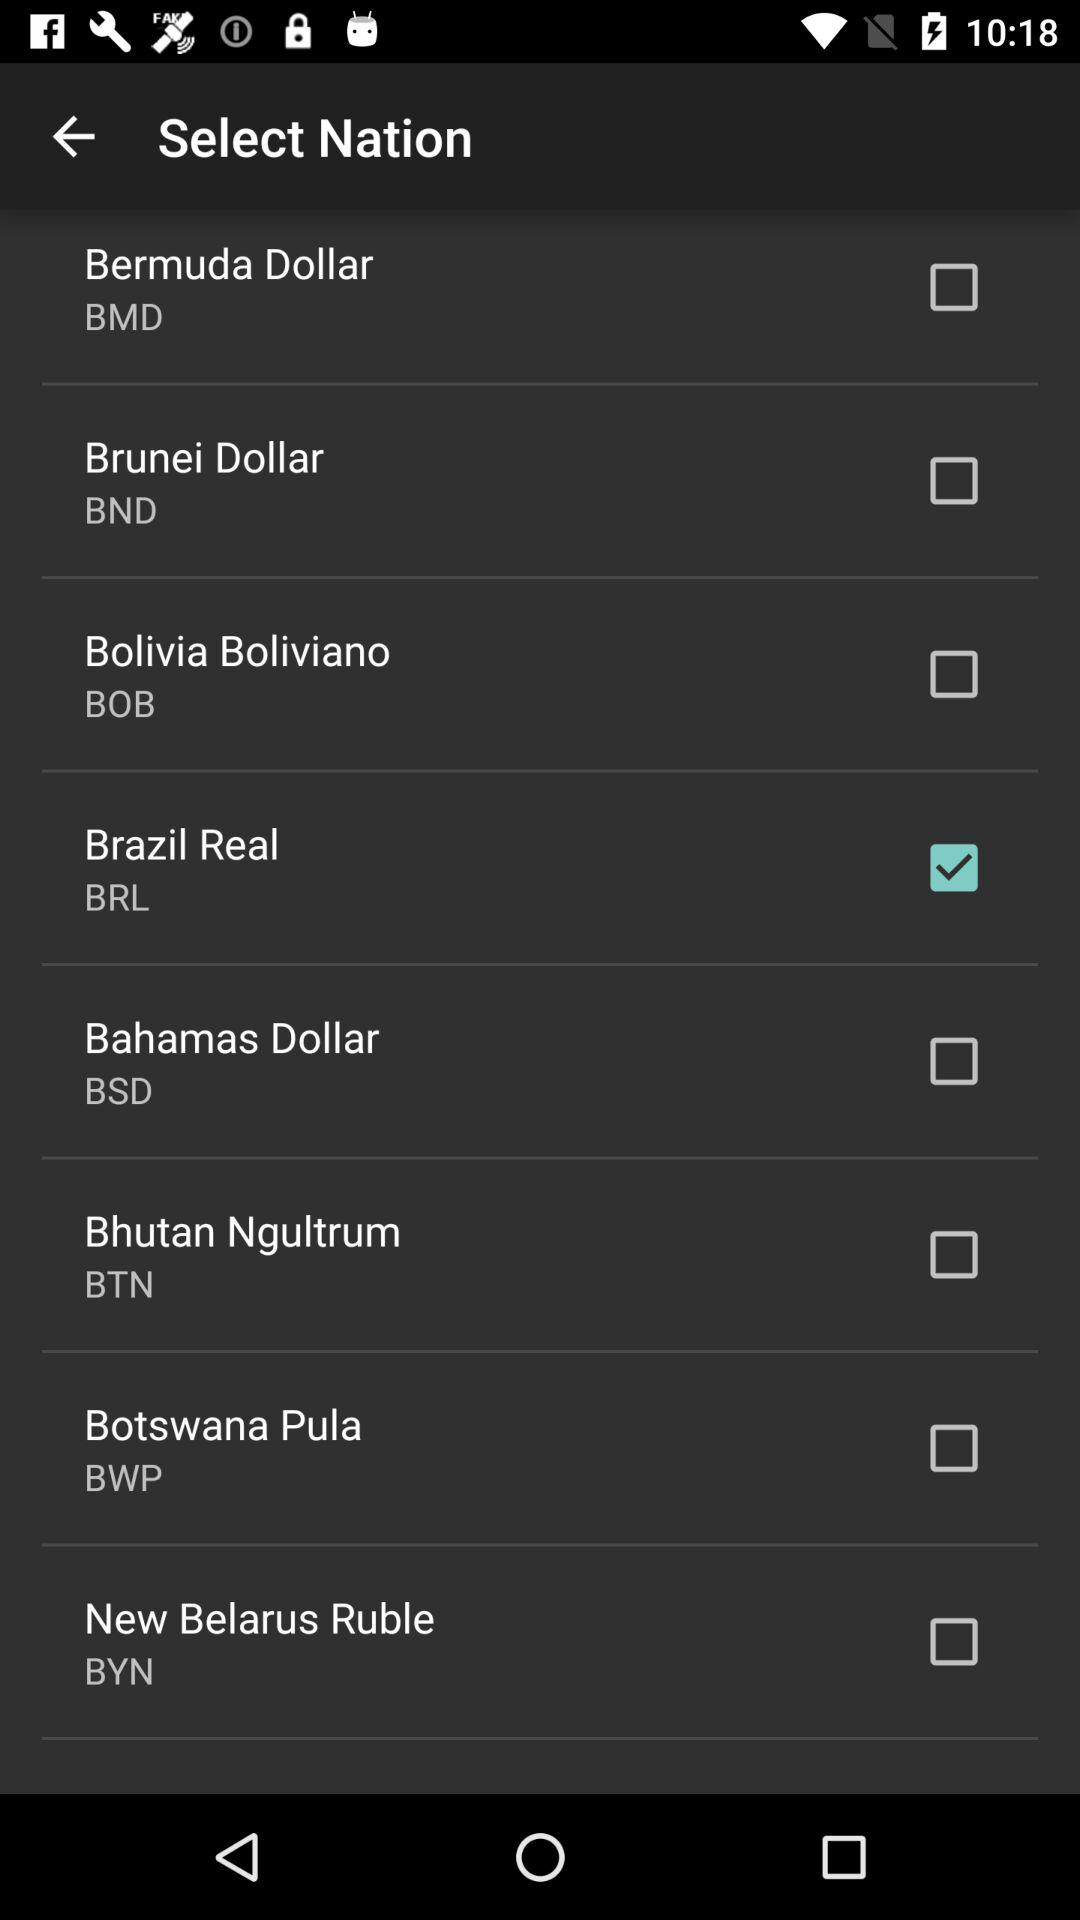Which tab are we on?
When the provided information is insufficient, respond with <no answer>. <no answer> 